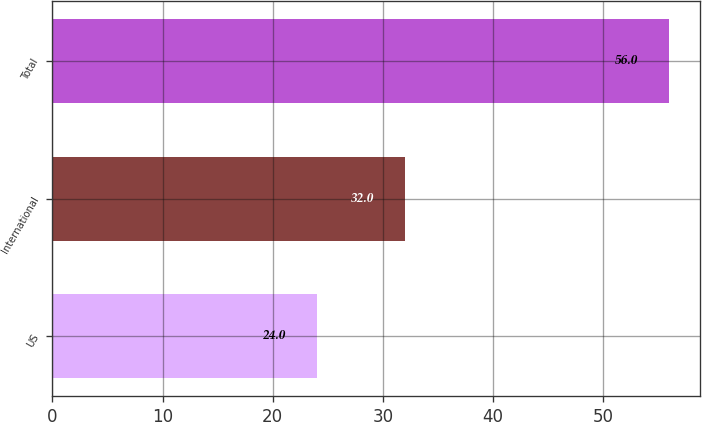<chart> <loc_0><loc_0><loc_500><loc_500><bar_chart><fcel>US<fcel>International<fcel>Total<nl><fcel>24<fcel>32<fcel>56<nl></chart> 